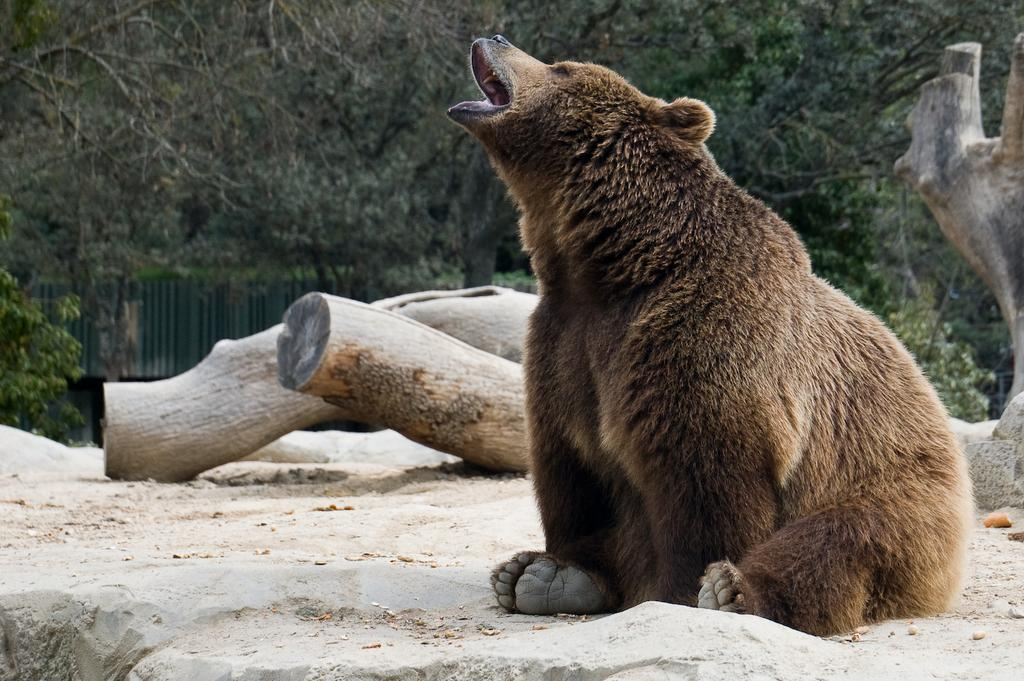What type of animal can be seen in the image? There is an animal in the image, but we cannot determine its exact species from the provided facts. What is the surface on which the animal is standing? There is ground visible in the image, and the animal is standing on it. What other objects are present on the ground? There are objects like wood on the ground. What type of vegetation is visible in the image? There are trees in the image. What type of barrier is present in the image? There is a fence in the image. What reward does the animal receive for crossing the fence in the image? There is no indication in the image that the animal is receiving a reward for crossing the fence, nor is there any mention of a reward in the provided facts. 